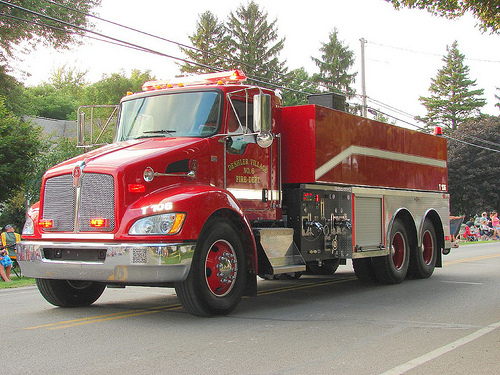<image>
Can you confirm if the truck is next to the person? Yes. The truck is positioned adjacent to the person, located nearby in the same general area. 